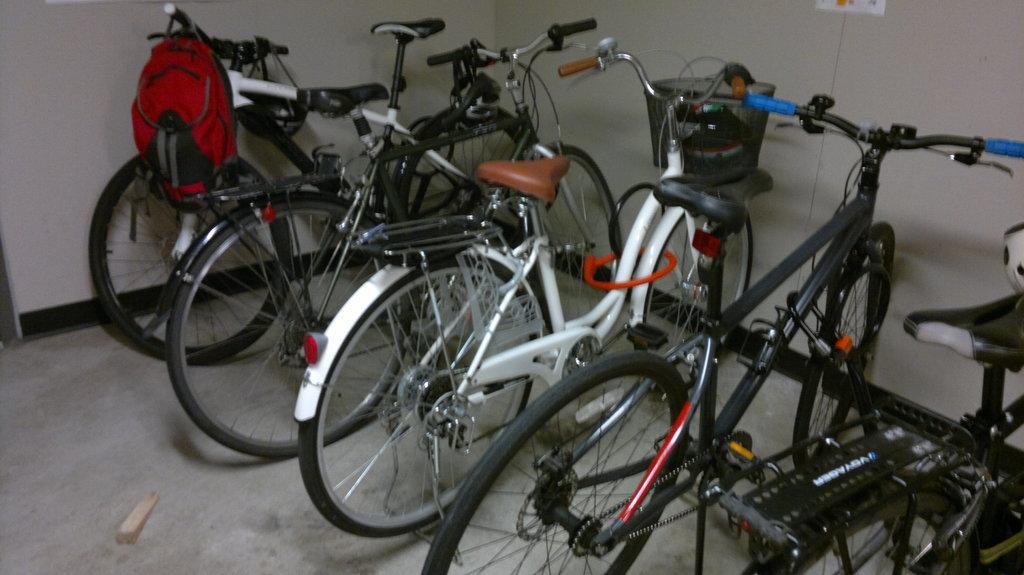What objects are on the floor in the image? There are bicycles on the floor in the image. Is there anything attached to the bicycles? Yes, there is a red color bag hanged to the handle of one of the bicycles. What can be seen in the background of the image? There is a white color wall in the background of the image. What type of flesh can be seen on the bicycles in the image? There is no flesh present on the bicycles in the image; they are inanimate objects made of metal and other materials. 